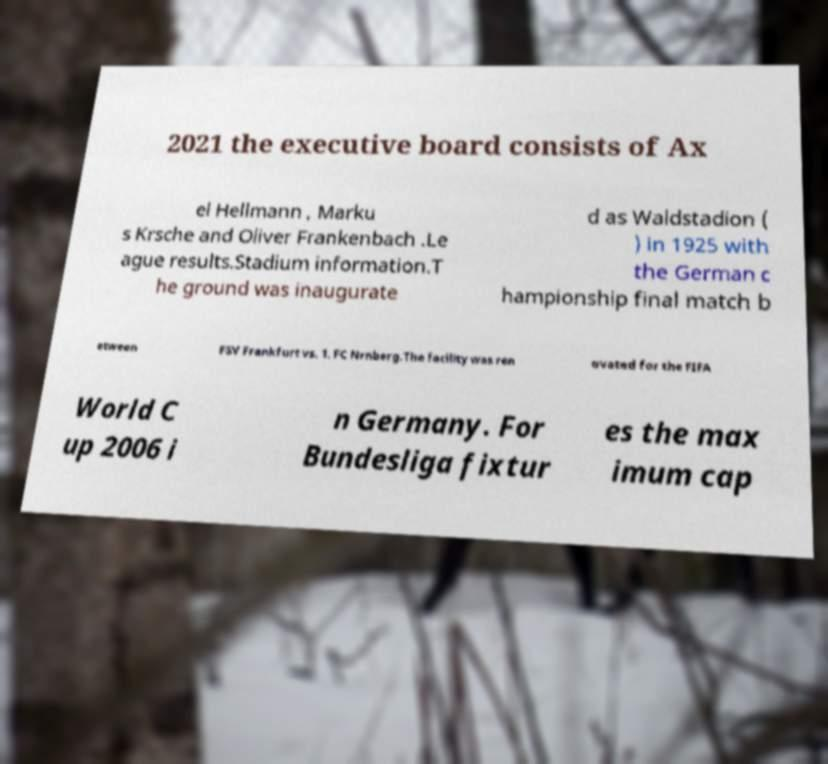I need the written content from this picture converted into text. Can you do that? 2021 the executive board consists of Ax el Hellmann , Marku s Krsche and Oliver Frankenbach .Le ague results.Stadium information.T he ground was inaugurate d as Waldstadion ( ) in 1925 with the German c hampionship final match b etween FSV Frankfurt vs. 1. FC Nrnberg.The facility was ren ovated for the FIFA World C up 2006 i n Germany. For Bundesliga fixtur es the max imum cap 